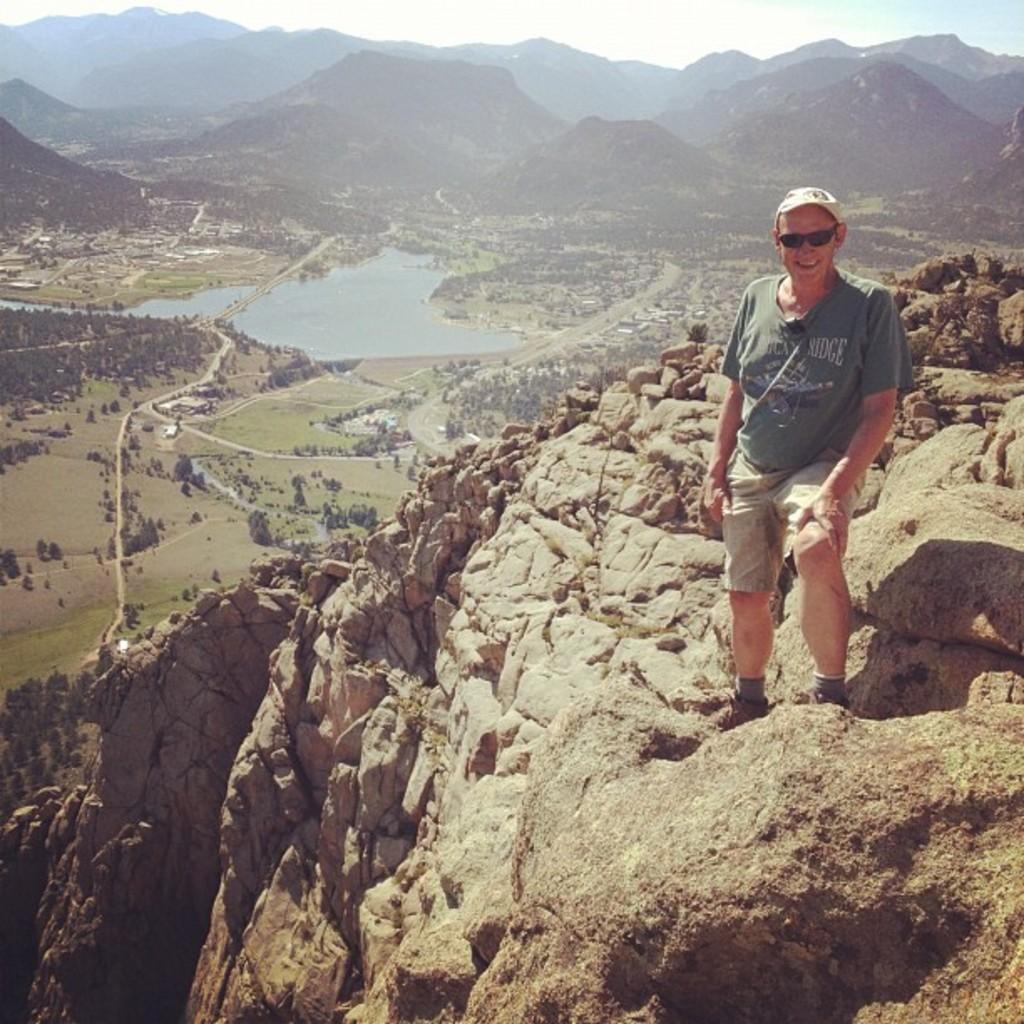What is the man in the image doing? The man is standing on a rock in the image. What can be seen in the background of the image? There is water, trees, hills, and the sky visible in the background of the image. How many legs can be seen on the spiders in the image? There are no spiders present in the image, so it is not possible to determine the number of legs on any spiders. 